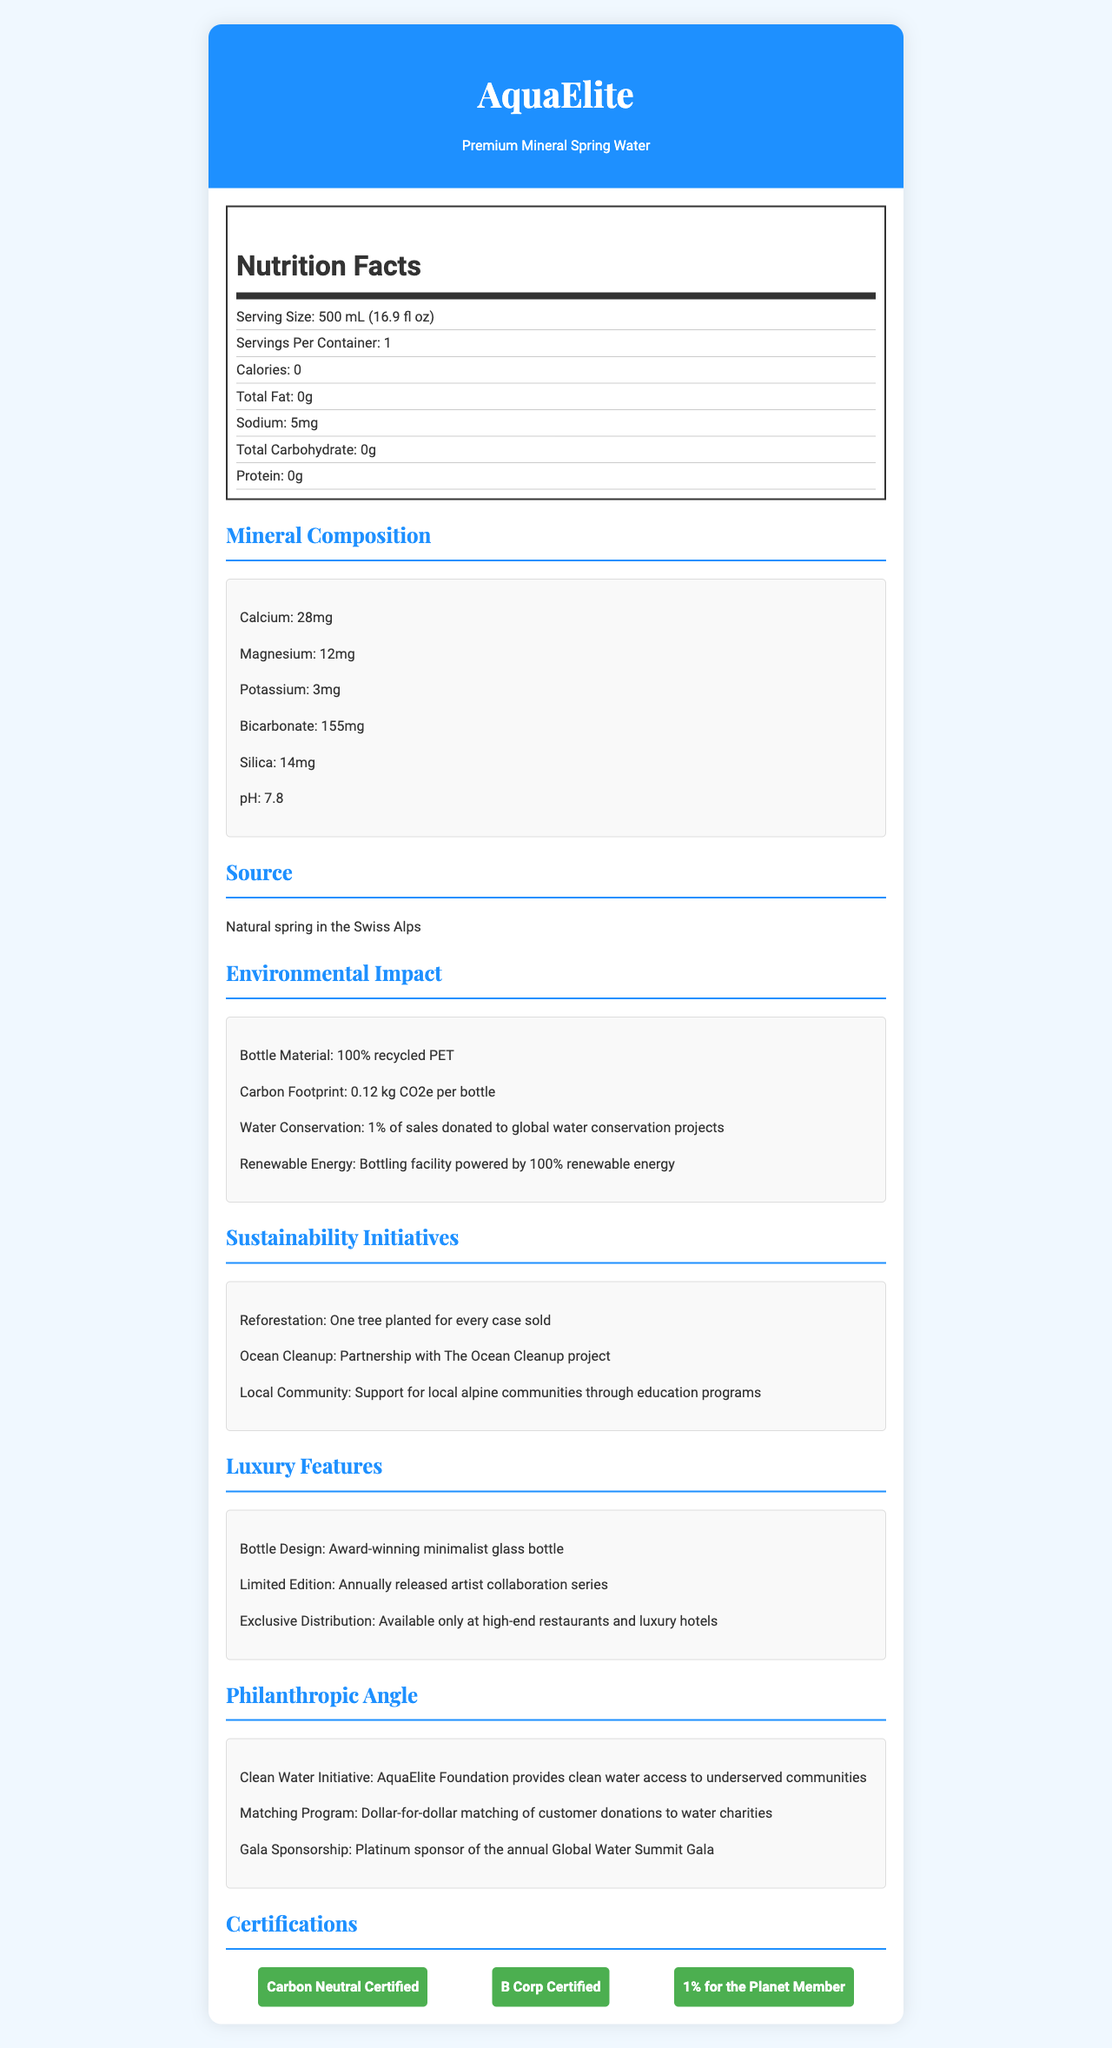what is the brand name of the product? The brand name is clearly mentioned at the top of the document as AquaElite.
Answer: AquaElite how many servings are in one container? The document states "Servings Per Container: 1" in the Nutrition Facts section.
Answer: 1 what is the source of the water? The source is specified under the "Source" section as "Natural spring in the Swiss Alps."
Answer: Natural spring in the Swiss Alps how much sodium does one serving contain? The Nutrition Facts indicate that there is 5mg of Sodium per serving.
Answer: 5mg what is the pH level of the water? The pH level of the water is listed in the Mineral Composition section as 7.8.
Answer: 7.8 which mineral is present in the highest amount in the water? A. Calcium B. Magnesium C. Potassium D. Silica The Mineral Composition section lists the amounts of minerals, and Calcium has the highest value at 28mg.
Answer: A. Calcium which of the following initiatives is part of AquaElite's environmental impact efforts? I. Renewable energy II. Ocean cleanup III. Water conservation The "Environmental Impact" section mentions "renewable energy" and "water conservation," while "environmental cleanup" is under "Sustainability Initiatives."
Answer: I, III is the bottled water carbon neutral? The certification section includes "Carbon Neutral Certified," indicating that the bottled water is carbon neutral.
Answer: Yes what special distribution strategy does AquaElite use? The Luxury Features section mentions "Available only at high-end restaurants and luxury hotels" as part of its exclusive distribution strategy.
Answer: Available only at high-end restaurants and luxury hotels describe the luxury features of AquaElite's bottled water. The document lists several luxury features, including an award-winning minimalist glass bottle design, a limited edition artist collaboration series, and exclusive distribution at premium locations.
Answer: Award-winning minimalist glass bottle, annually released artist collaboration series, exclusive distribution at high-end restaurants and luxury hotels. what is the exact amount of silica in the water? The Mineral Composition section specifies 14mg of Silica.
Answer: 14mg what percentage of sales is donated to global water conservation projects? The Environmental Impact section states that 1% of sales are donated to global water conservation projects.
Answer: 1% what is the nutritional information used to determine flavor additives? The document does not provide any information about flavor additives based on the presented Nutrition Facts.
Answer: Cannot be determined how does AquaElite support local alpine communities? The Sustainability Initiatives section mentions support for local alpine communities through education programs.
Answer: Through education programs what are the certifications that AquaElite has achieved? These certifications are listed in the "Certifications" section.
Answer: Carbon Neutral Certified, B Corp Certified, 1% for the Planet Member what is AquaElite's clean water initiative? The Philanthropic Angle section states that the AquaElite Foundation provides clean water access to underserved communities.
Answer: Provides clean water access to underserved communities summarize the main idea of the document. The document is a comprehensive presentation of various features and commitments associated with AquaElite's Premium Mineral Spring Water, emphasizing its luxury status, eco-friendly practices, and philanthropic activities.
Answer: The document presents detailed information about AquaElite's Premium Mineral Spring Water, including its nutrition facts, mineral composition, environmental impact, sustainability initiatives, luxury features, and philanthropic efforts. It highlights the brand’s commitment to quality, environmental sustainability, and social responsibility. 